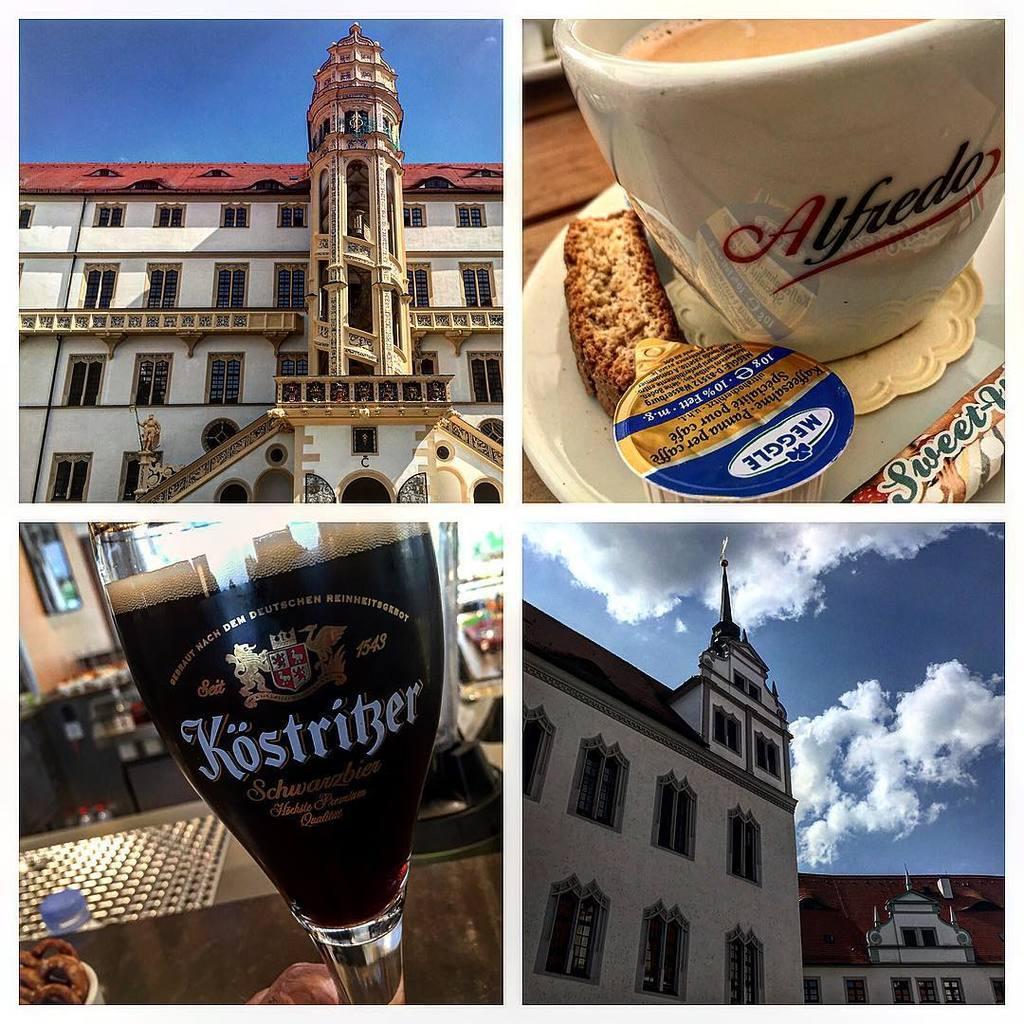How would you summarize this image in a sentence or two? In this picture we can see grid image of two buildings and two drinks on left side of the image there is a building which is in white and red color, there is some drink in wine glass, on right side of the image there is coffee cup and other building which is also in red and white color. 